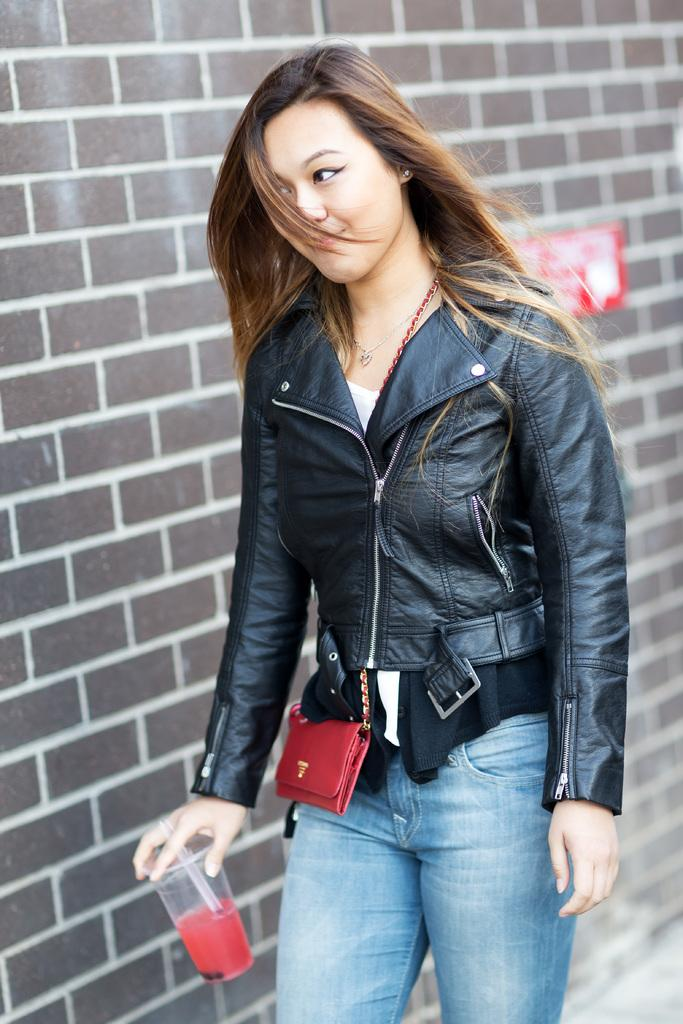What is the main subject of the image? There is a woman in the image. What is the woman holding in the image? The woman is holding a glass. What can be seen in the background of the image? There is a wall in the background of the image. How many pizzas are stacked on the table in the image? There is no table or pizzas present in the image. What is the height of the woman in the image? The height of the woman cannot be determined from the image alone. 